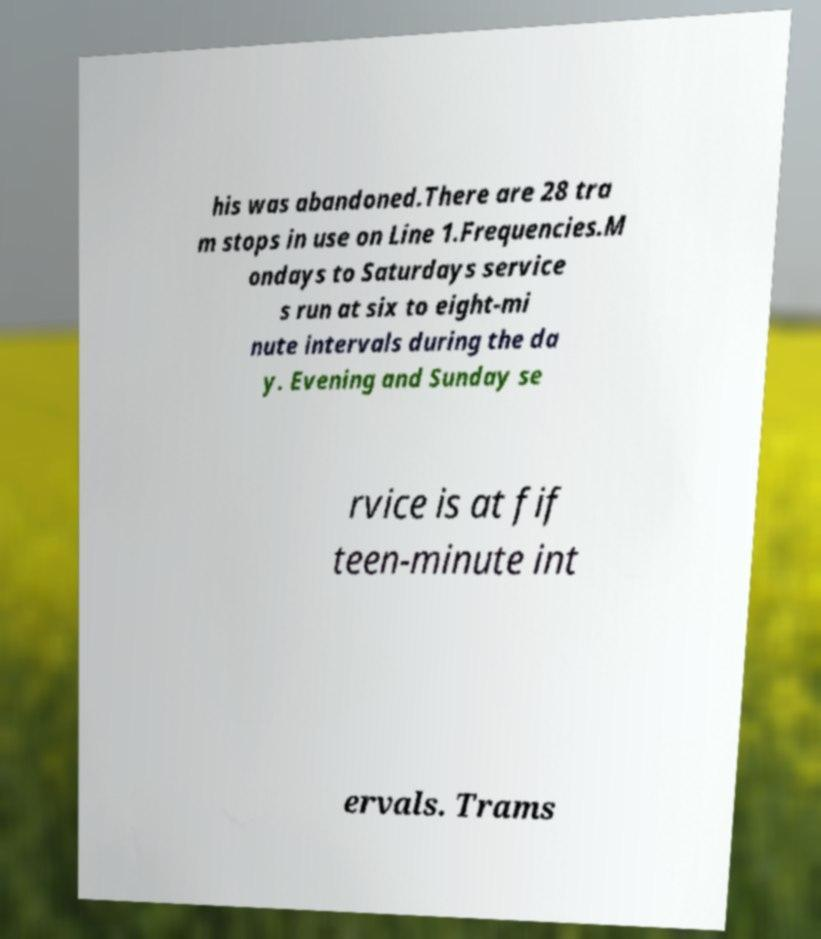Can you read and provide the text displayed in the image?This photo seems to have some interesting text. Can you extract and type it out for me? his was abandoned.There are 28 tra m stops in use on Line 1.Frequencies.M ondays to Saturdays service s run at six to eight-mi nute intervals during the da y. Evening and Sunday se rvice is at fif teen-minute int ervals. Trams 